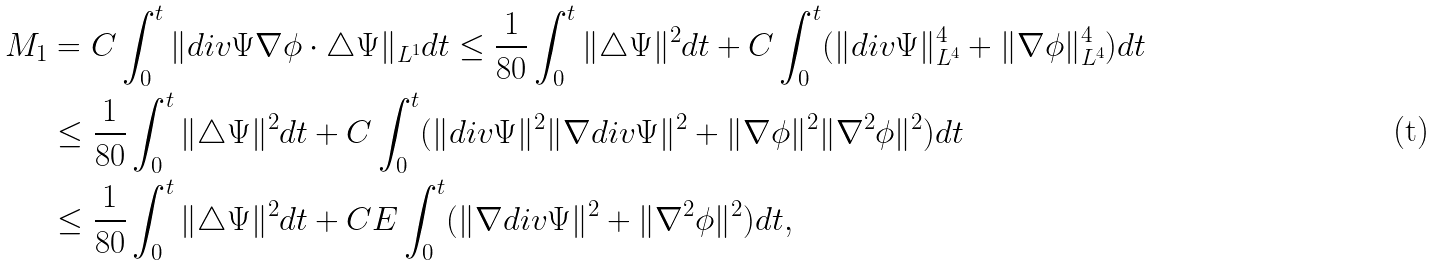Convert formula to latex. <formula><loc_0><loc_0><loc_500><loc_500>M _ { 1 } & = C \int _ { 0 } ^ { t } \| d i v \Psi \nabla \phi \cdot \triangle \Psi \| _ { L ^ { 1 } } d t \leq \frac { 1 } { 8 0 } \int _ { 0 } ^ { t } \| \triangle \Psi \| ^ { 2 } d t + C \int _ { 0 } ^ { t } ( \| d i v \Psi \| _ { L ^ { 4 } } ^ { 4 } + \| \nabla \phi \| _ { L ^ { 4 } } ^ { 4 } ) d t \\ & \leq \frac { 1 } { 8 0 } \int _ { 0 } ^ { t } \| \triangle \Psi \| ^ { 2 } d t + C \int _ { 0 } ^ { t } ( \| d i v \Psi \| ^ { 2 } \| \nabla d i v \Psi \| ^ { 2 } + \| \nabla \phi \| ^ { 2 } \| \nabla ^ { 2 } \phi \| ^ { 2 } ) d t \\ & \leq \frac { 1 } { 8 0 } \int _ { 0 } ^ { t } \| \triangle \Psi \| ^ { 2 } d t + C E \int _ { 0 } ^ { t } ( \| \nabla d i v \Psi \| ^ { 2 } + \| \nabla ^ { 2 } \phi \| ^ { 2 } ) d t ,</formula> 